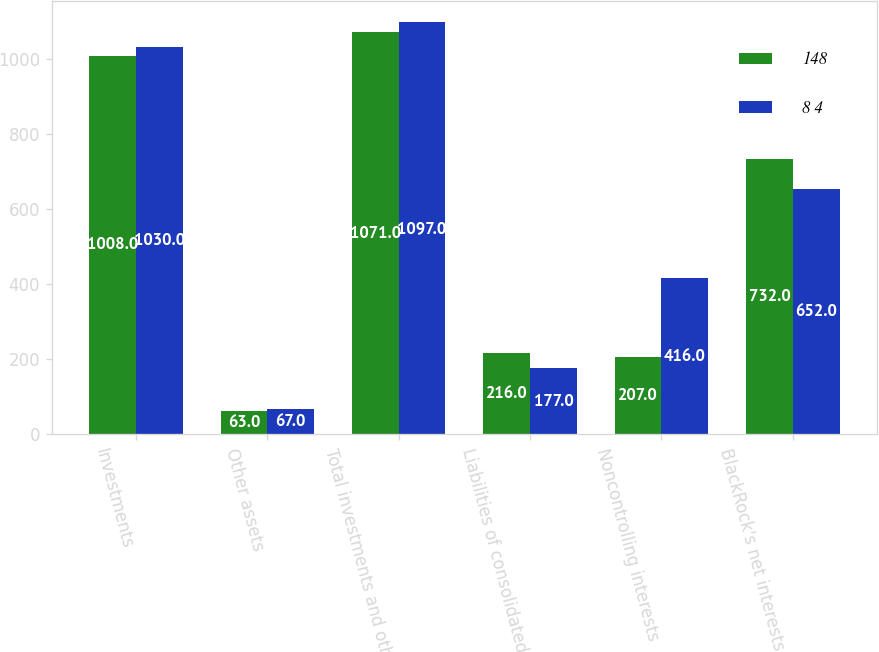Convert chart to OTSL. <chart><loc_0><loc_0><loc_500><loc_500><stacked_bar_chart><ecel><fcel>Investments<fcel>Other assets<fcel>Total investments and other<fcel>Liabilities of consolidated<fcel>Noncontrolling interests<fcel>BlackRock's net interests in<nl><fcel>148<fcel>1008<fcel>63<fcel>1071<fcel>216<fcel>207<fcel>732<nl><fcel>8 4<fcel>1030<fcel>67<fcel>1097<fcel>177<fcel>416<fcel>652<nl></chart> 